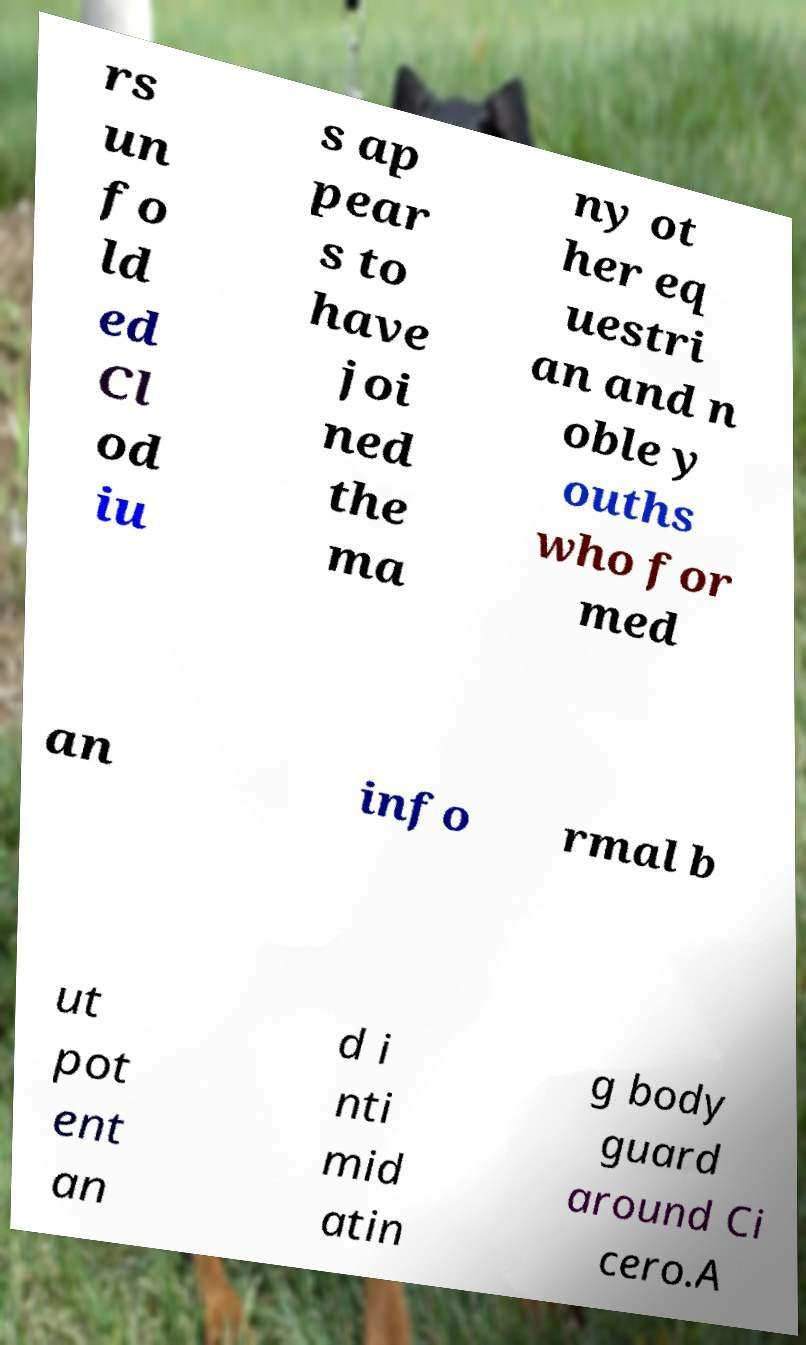For documentation purposes, I need the text within this image transcribed. Could you provide that? rs un fo ld ed Cl od iu s ap pear s to have joi ned the ma ny ot her eq uestri an and n oble y ouths who for med an info rmal b ut pot ent an d i nti mid atin g body guard around Ci cero.A 